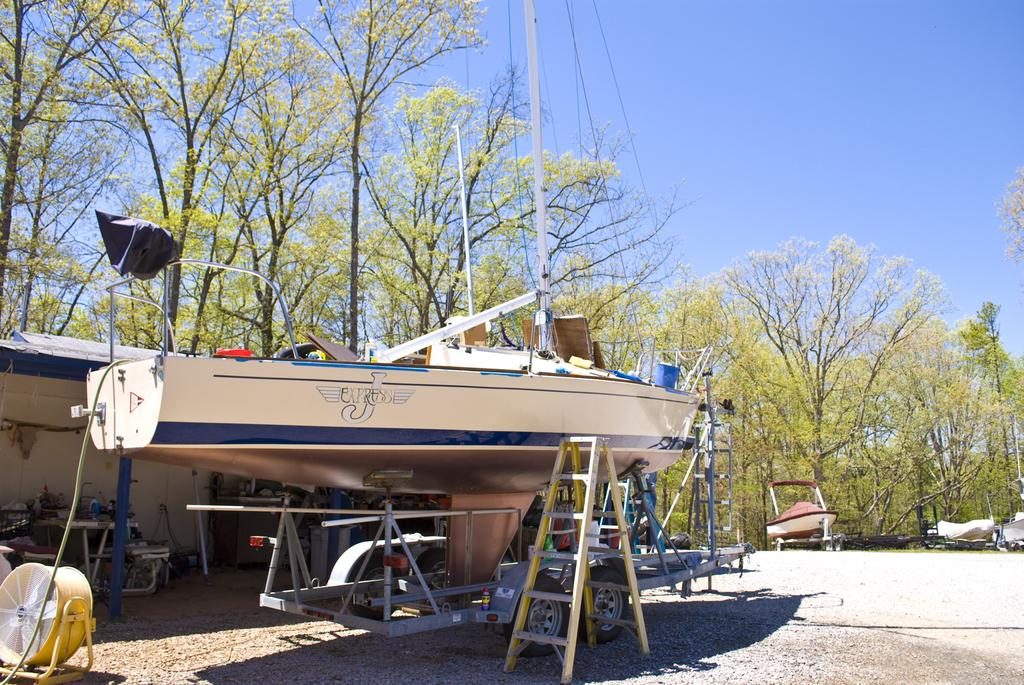What is the main object in the image? There is a boat on a stand in the image. What is located near the boat? There is a ladder near the boat. What can be seen in the background of the image? There is a building and trees in the background, as well as the sky. What type of ring can be seen on the boat in the image? There is no ring present on the boat in the image. What is the boat using to cook food in the image? The boat does not have an oven or any cooking equipment in the image. 